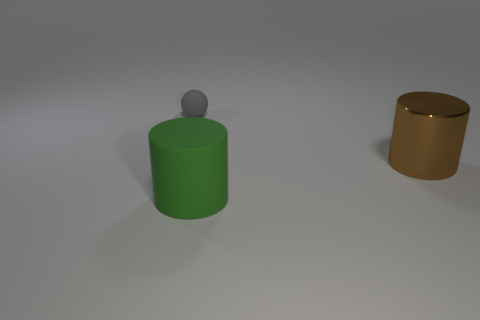Add 1 small gray shiny spheres. How many objects exist? 4 Subtract 0 yellow blocks. How many objects are left? 3 Subtract all cylinders. How many objects are left? 1 Subtract all brown rubber blocks. Subtract all gray objects. How many objects are left? 2 Add 3 metal objects. How many metal objects are left? 4 Add 3 large cylinders. How many large cylinders exist? 5 